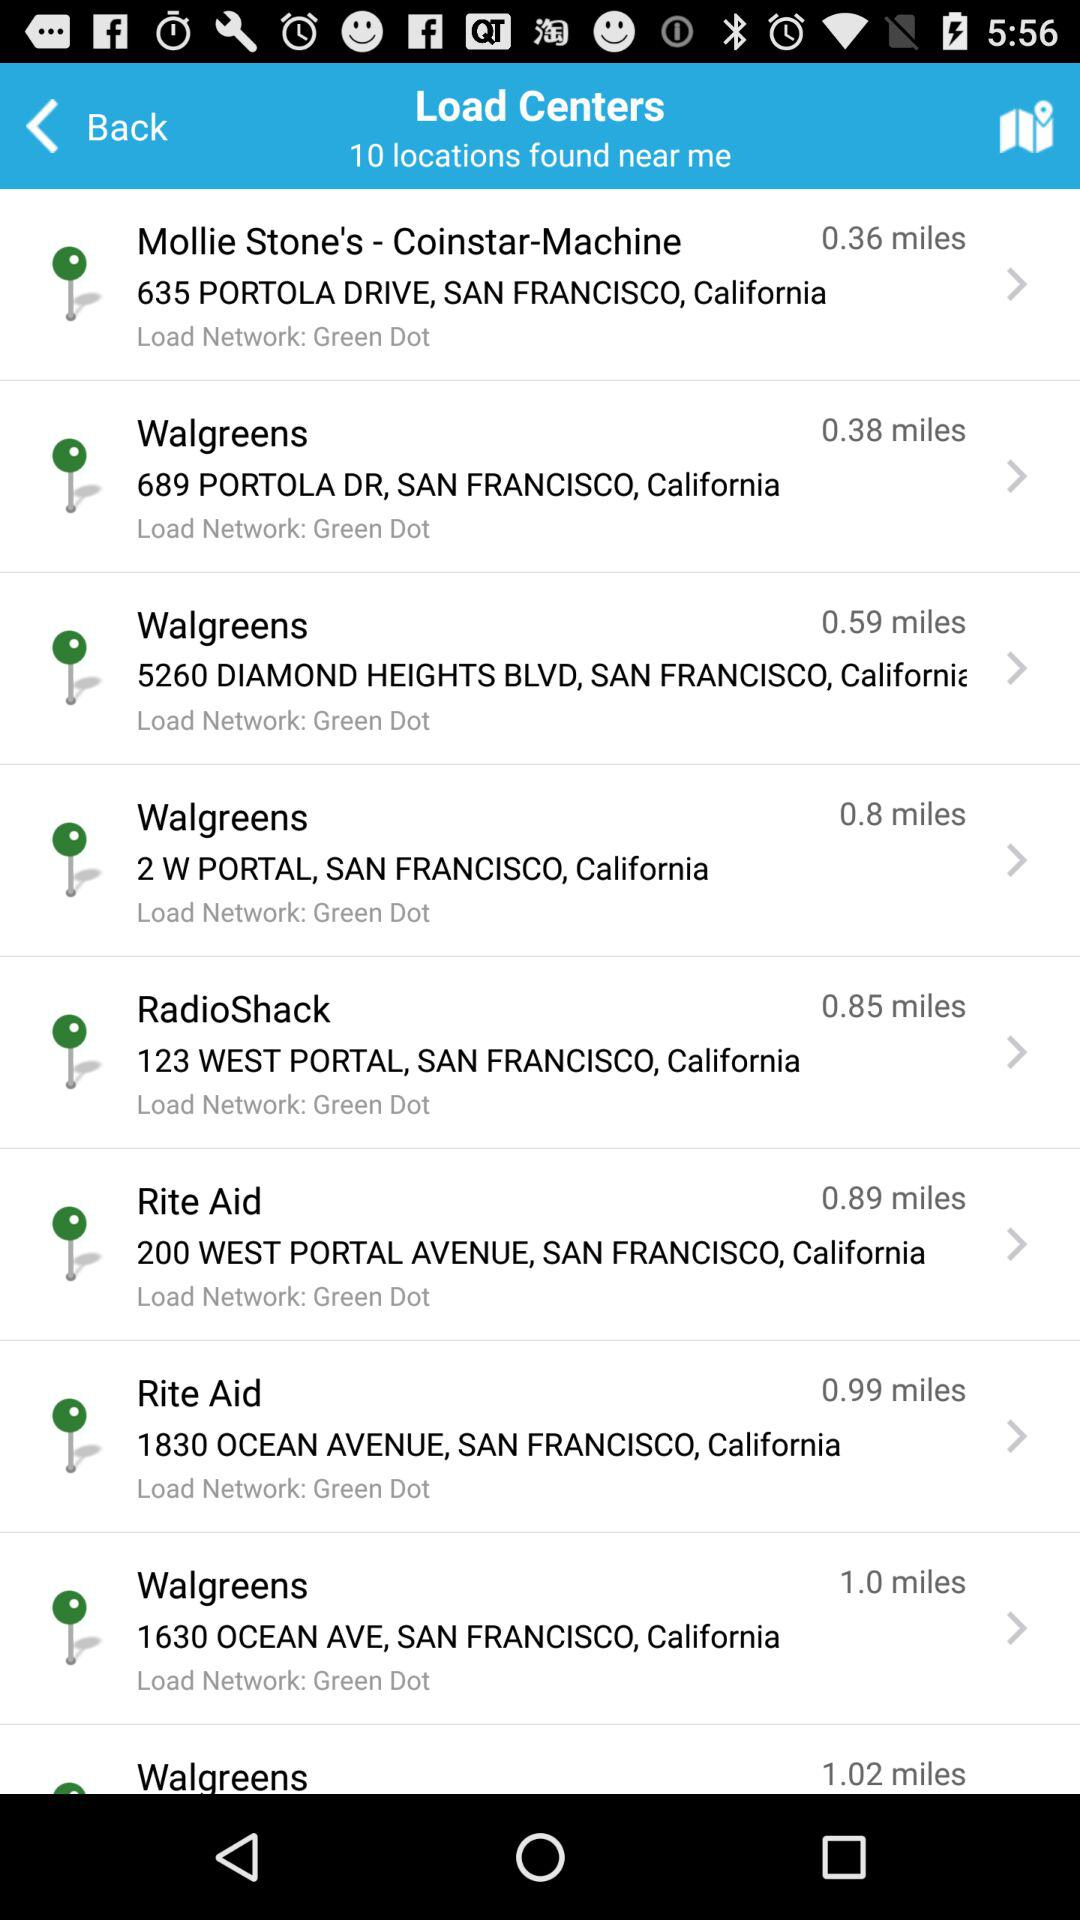Which location is 0.36 miles away? The location is 635 Portola Drive, San Francisco, California. 